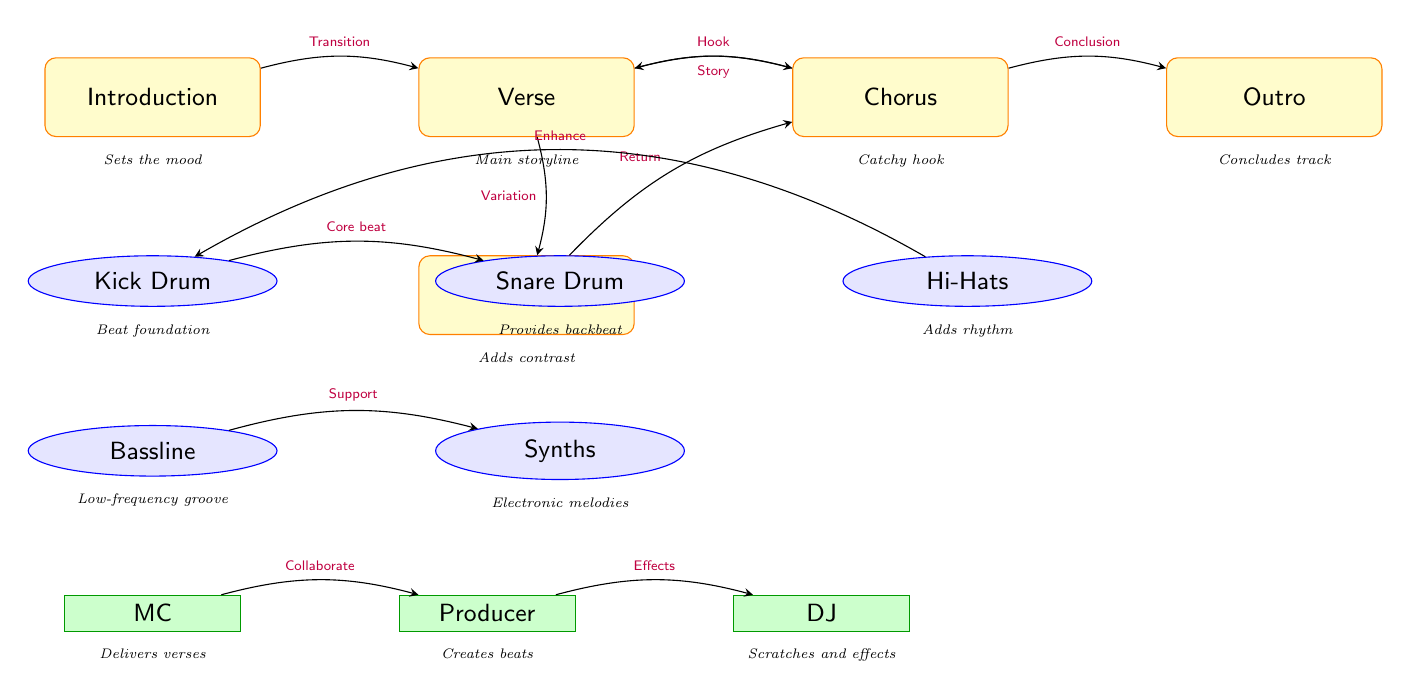What are the main sections of a hip hop/electronic track? The diagram lists five main sections, which are: Introduction, Verse, Chorus, Bridge, and Outro. These sections represent the overall structure of the music track.
Answer: Introduction, Verse, Chorus, Bridge, Outro How many instruments are illustrated in the diagram? The diagram includes five instruments: Kick Drum, Snare Drum, Hi-Hats, Bassline, and Synths. By counting each distinct instrument node, we find there are five.
Answer: 5 What does the Kick Drum provide in a track? According to the descriptions in the diagram, the Kick Drum provides the "Beat foundation." This indicates its essential role in establishing the core rhythm of the track.
Answer: Beat foundation What is the relationship between the Verse and Chorus sections? The diagram shows that the Verse transitions to the Chorus as indicated by the arrow labeled "Hook." This signifies that the Chorus follows after the Verse and is connected through this specific relationship.
Answer: Hook Which person is responsible for delivering verses in the track? The diagram labels the "MC" as the person responsible for delivering verses. This is clearly stated in the person node associated with the MC.
Answer: MC What are the roles of the Producer and DJ in the track? The Producer is described as "Creates beats" and the DJ as "Scratches and effects." Therefore, the Producer focuses on beat creation while the DJ adds scratches and sound effects, contributing to the overall sound.
Answer: Creates beats, Scratches and effects What happens after the Bridge in the flow of the track? The diagram indicates that after the Bridge, there is a return to the Chorus, as depicted by the arrow labeled "Return." This shows the flow of the track structure moving from the Bridge back to the Chorus section.
Answer: Return What supports the Synths in the instrumentation? The diagram states that the Bassline provides "Support" for the Synths. This means that the Bassline works together with the Synths to enhance the overall sound of the track.
Answer: Support What would the Outro do in the structure of the track? The diagram describes the Outro as the section that "Concludes track." This signifies its role in wrapping up the entire musical composition.
Answer: Concludes track 